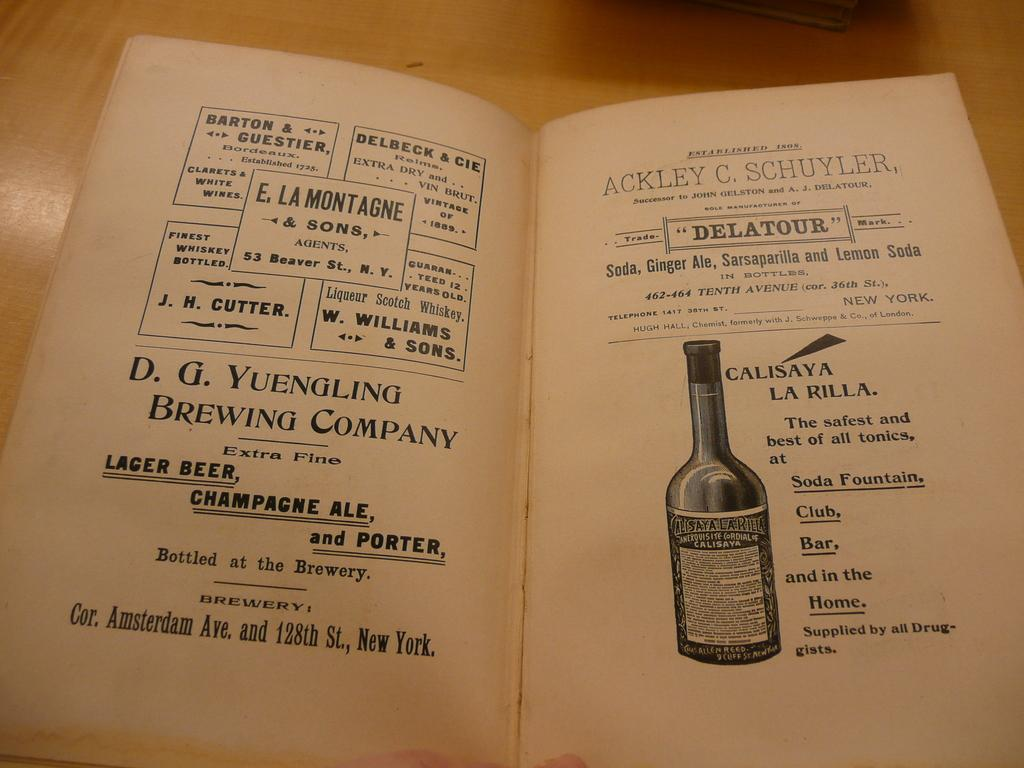Where was the image taken? The image is taken indoors. What can be seen on the table in the image? There is a book on the table. What is depicted in the book? There is an image of a bottle in the book. What else is present in the book besides the image? There is text in the book. What type of necklace is shown in the image? There is no necklace present in the image; it features a book with an image of a bottle and text. What season is depicted in the image? The image does not depict a specific season; it is taken indoors and features a book with an image of a bottle and text. 